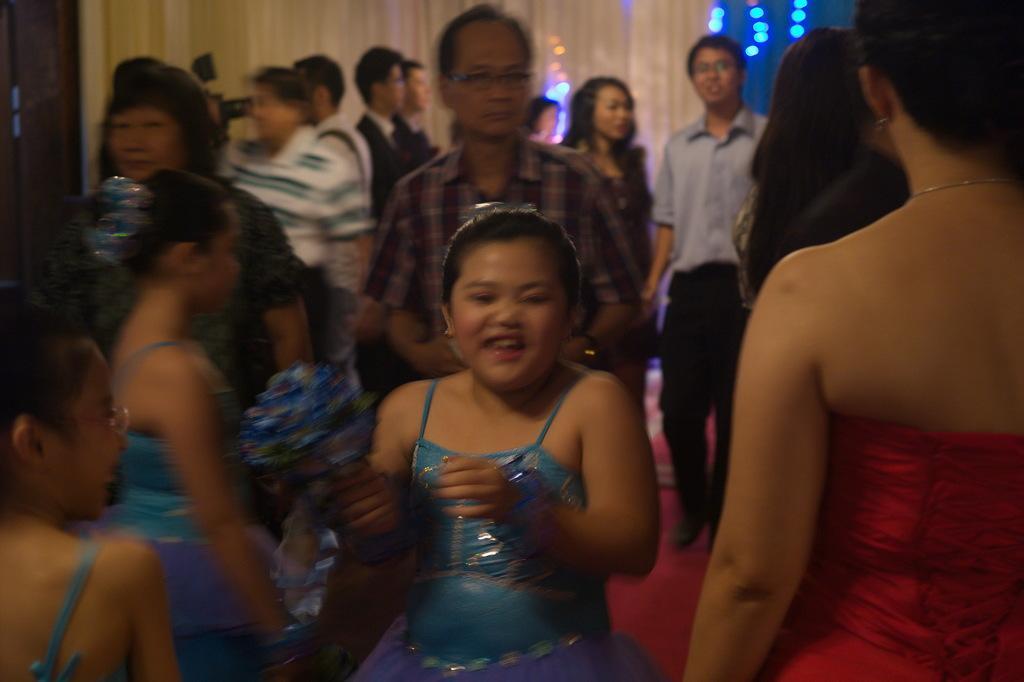How would you summarize this image in a sentence or two? In this picture we can see some people standing, in the background there are some lights and curtains, a girl in the front is smiling. 